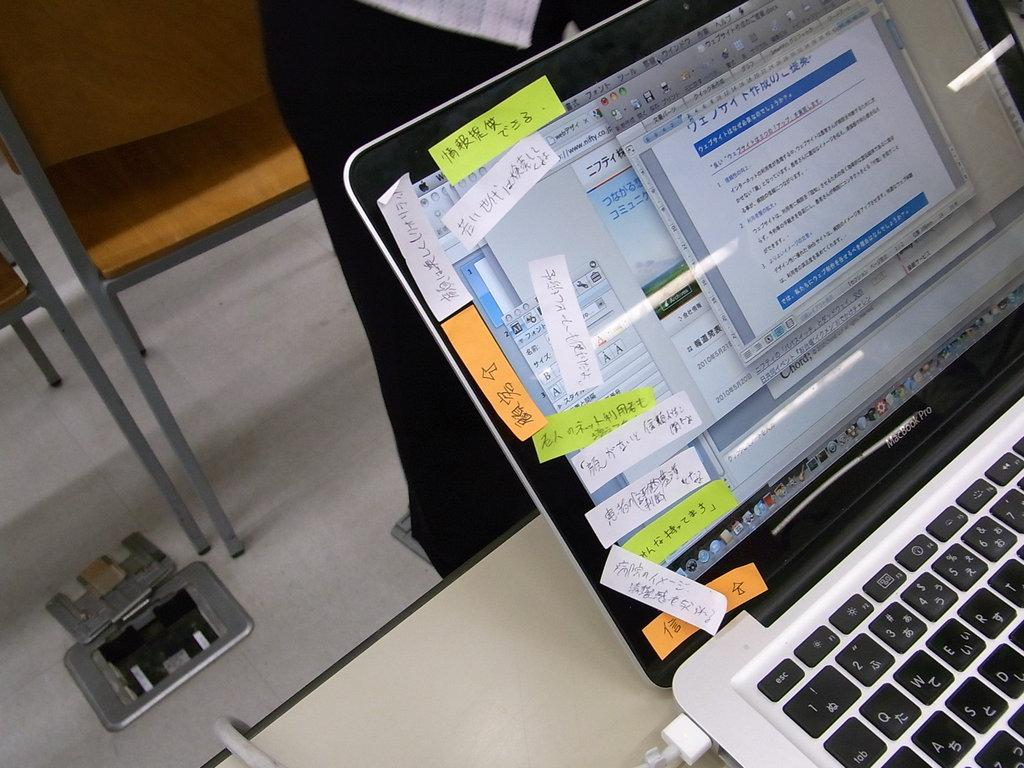<image>
Relay a brief, clear account of the picture shown. The laptop has keys with more than one symbol on all of them except for the esc key. 